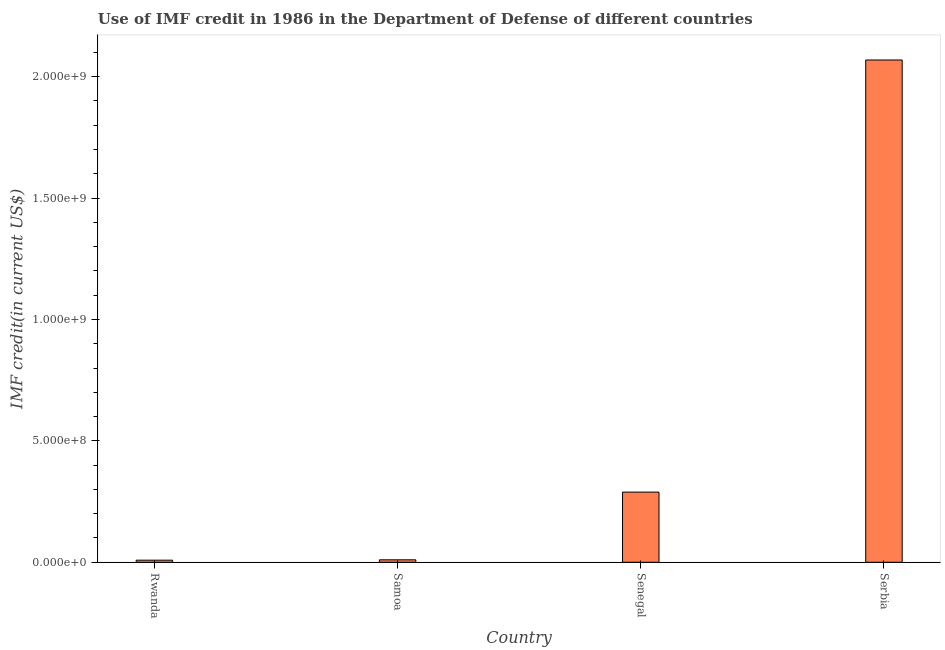Does the graph contain any zero values?
Your response must be concise. No. What is the title of the graph?
Provide a succinct answer. Use of IMF credit in 1986 in the Department of Defense of different countries. What is the label or title of the X-axis?
Your answer should be compact. Country. What is the label or title of the Y-axis?
Your answer should be compact. IMF credit(in current US$). What is the use of imf credit in dod in Senegal?
Your answer should be compact. 2.89e+08. Across all countries, what is the maximum use of imf credit in dod?
Offer a very short reply. 2.07e+09. Across all countries, what is the minimum use of imf credit in dod?
Ensure brevity in your answer.  8.59e+06. In which country was the use of imf credit in dod maximum?
Offer a very short reply. Serbia. In which country was the use of imf credit in dod minimum?
Give a very brief answer. Rwanda. What is the sum of the use of imf credit in dod?
Provide a succinct answer. 2.38e+09. What is the difference between the use of imf credit in dod in Samoa and Senegal?
Your answer should be compact. -2.79e+08. What is the average use of imf credit in dod per country?
Provide a succinct answer. 5.94e+08. What is the median use of imf credit in dod?
Give a very brief answer. 1.50e+08. What is the ratio of the use of imf credit in dod in Samoa to that in Senegal?
Make the answer very short. 0.04. Is the difference between the use of imf credit in dod in Samoa and Senegal greater than the difference between any two countries?
Offer a very short reply. No. What is the difference between the highest and the second highest use of imf credit in dod?
Give a very brief answer. 1.78e+09. What is the difference between the highest and the lowest use of imf credit in dod?
Your response must be concise. 2.06e+09. In how many countries, is the use of imf credit in dod greater than the average use of imf credit in dod taken over all countries?
Your answer should be compact. 1. Are all the bars in the graph horizontal?
Provide a succinct answer. No. What is the IMF credit(in current US$) of Rwanda?
Your response must be concise. 8.59e+06. What is the IMF credit(in current US$) of Samoa?
Your answer should be very brief. 1.01e+07. What is the IMF credit(in current US$) of Senegal?
Provide a succinct answer. 2.89e+08. What is the IMF credit(in current US$) in Serbia?
Keep it short and to the point. 2.07e+09. What is the difference between the IMF credit(in current US$) in Rwanda and Samoa?
Give a very brief answer. -1.53e+06. What is the difference between the IMF credit(in current US$) in Rwanda and Senegal?
Provide a short and direct response. -2.80e+08. What is the difference between the IMF credit(in current US$) in Rwanda and Serbia?
Offer a terse response. -2.06e+09. What is the difference between the IMF credit(in current US$) in Samoa and Senegal?
Ensure brevity in your answer.  -2.79e+08. What is the difference between the IMF credit(in current US$) in Samoa and Serbia?
Offer a very short reply. -2.06e+09. What is the difference between the IMF credit(in current US$) in Senegal and Serbia?
Provide a short and direct response. -1.78e+09. What is the ratio of the IMF credit(in current US$) in Rwanda to that in Samoa?
Give a very brief answer. 0.85. What is the ratio of the IMF credit(in current US$) in Rwanda to that in Serbia?
Ensure brevity in your answer.  0. What is the ratio of the IMF credit(in current US$) in Samoa to that in Senegal?
Ensure brevity in your answer.  0.04. What is the ratio of the IMF credit(in current US$) in Samoa to that in Serbia?
Make the answer very short. 0.01. What is the ratio of the IMF credit(in current US$) in Senegal to that in Serbia?
Ensure brevity in your answer.  0.14. 